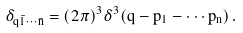<formula> <loc_0><loc_0><loc_500><loc_500>\delta _ { q \bar { 1 } \cdots \bar { n } } = ( 2 \pi ) ^ { 3 } \delta ^ { 3 } ( \vec { q } - \vec { p } _ { 1 } - \cdots \vec { p } _ { n } ) \, .</formula> 